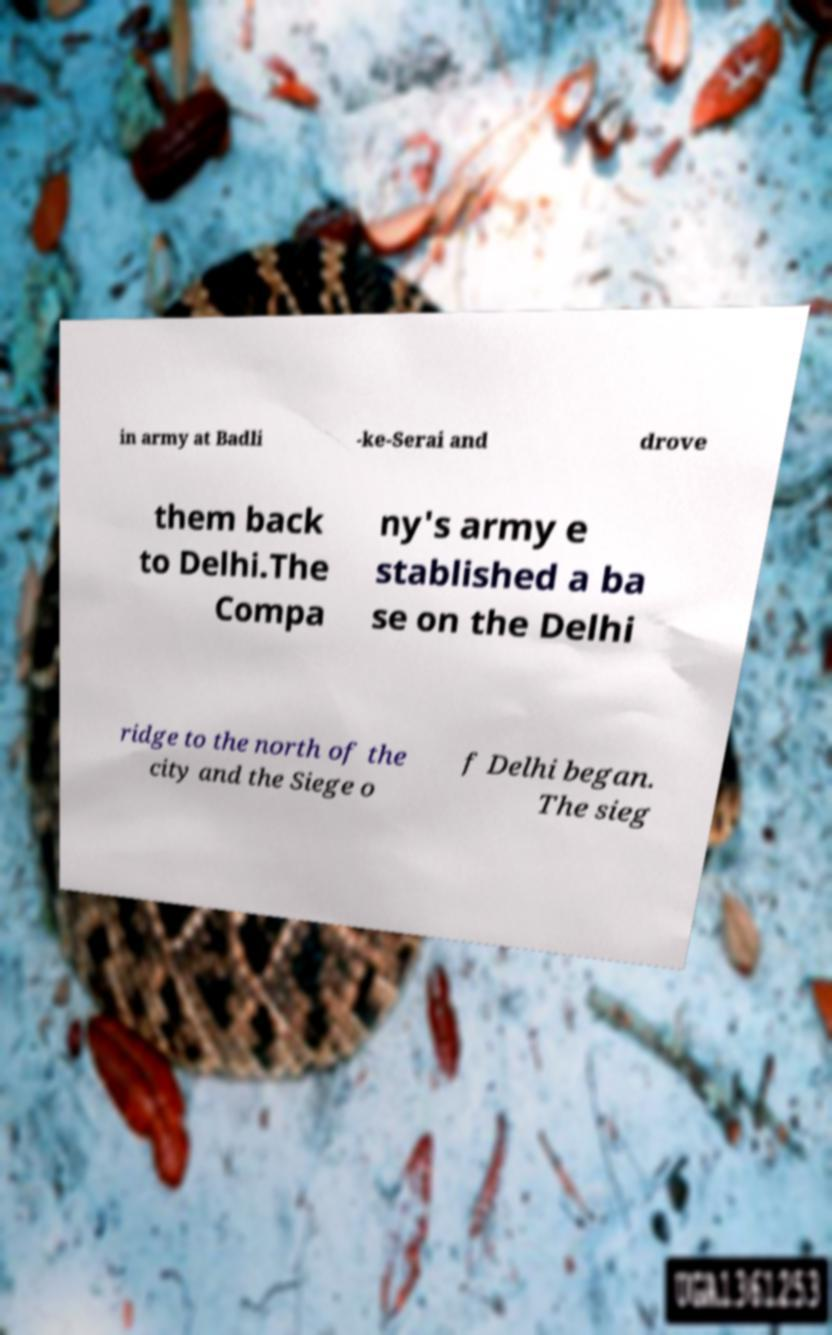I need the written content from this picture converted into text. Can you do that? in army at Badli -ke-Serai and drove them back to Delhi.The Compa ny's army e stablished a ba se on the Delhi ridge to the north of the city and the Siege o f Delhi began. The sieg 